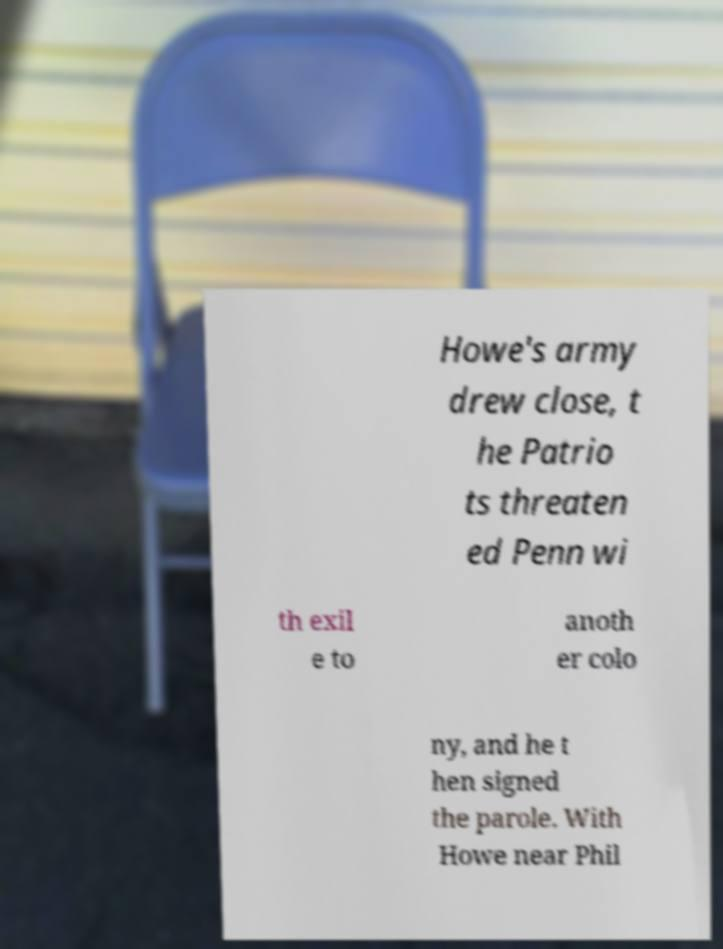For documentation purposes, I need the text within this image transcribed. Could you provide that? Howe's army drew close, t he Patrio ts threaten ed Penn wi th exil e to anoth er colo ny, and he t hen signed the parole. With Howe near Phil 